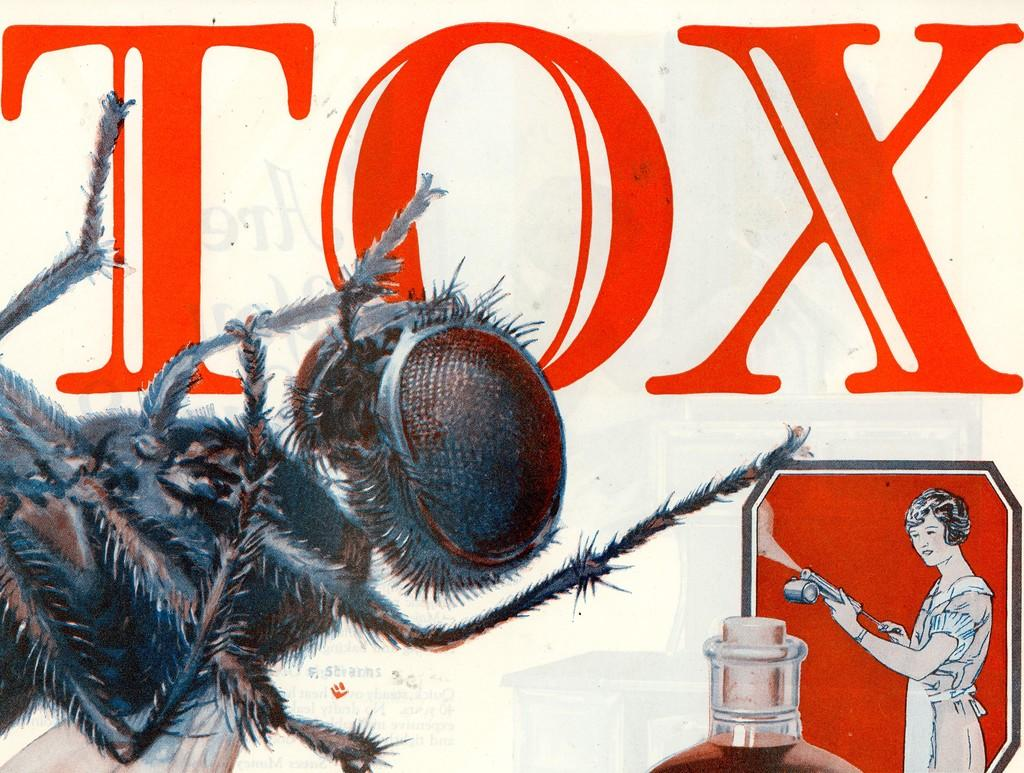What is depicted on the poster in the image? There is a poster of an insect in the image. Who is present in the image besides the insect? There is a woman in the image. What is the woman holding in the image? The woman is holding an object. What power source is used to keep the insect alive in the image? There is no indication in the image that the insect is alive or requires a power source. 